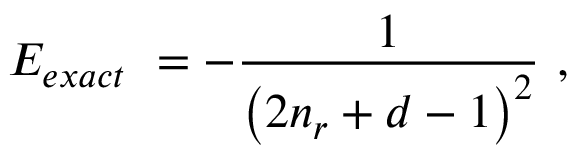Convert formula to latex. <formula><loc_0><loc_0><loc_500><loc_500>E _ { e x a c t } \ = - \frac { 1 } { \left ( 2 n _ { r } + d - 1 \right ) ^ { 2 } } \ ,</formula> 